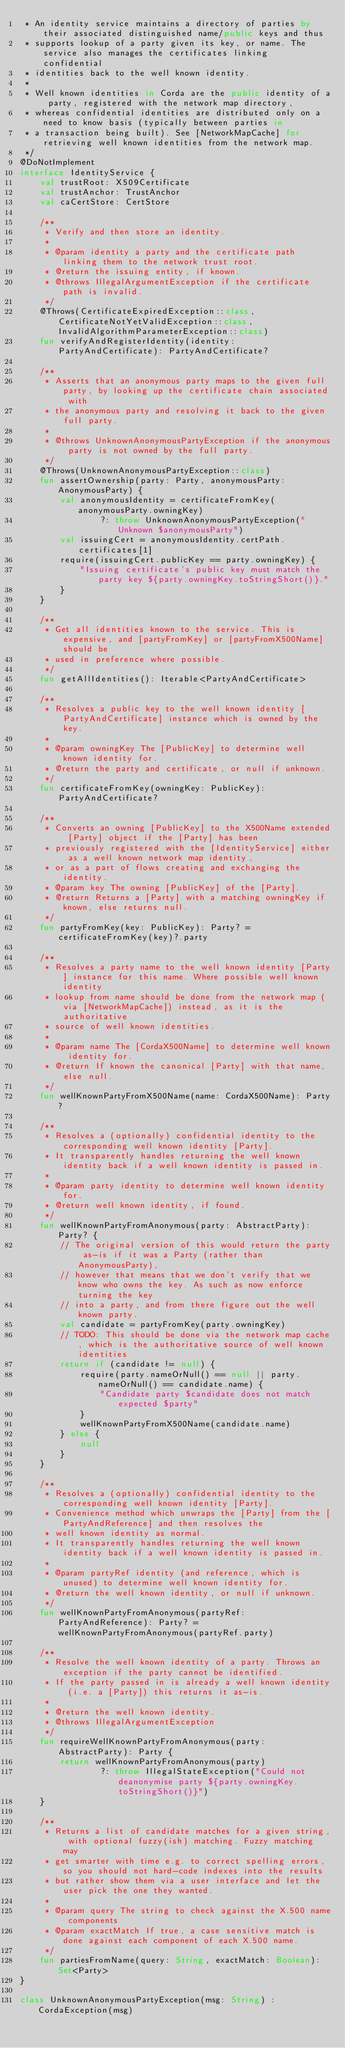Convert code to text. <code><loc_0><loc_0><loc_500><loc_500><_Kotlin_> * An identity service maintains a directory of parties by their associated distinguished name/public keys and thus
 * supports lookup of a party given its key, or name. The service also manages the certificates linking confidential
 * identities back to the well known identity.
 *
 * Well known identities in Corda are the public identity of a party, registered with the network map directory,
 * whereas confidential identities are distributed only on a need to know basis (typically between parties in
 * a transaction being built). See [NetworkMapCache] for retrieving well known identities from the network map.
 */
@DoNotImplement
interface IdentityService {
    val trustRoot: X509Certificate
    val trustAnchor: TrustAnchor
    val caCertStore: CertStore

    /**
     * Verify and then store an identity.
     *
     * @param identity a party and the certificate path linking them to the network trust root.
     * @return the issuing entity, if known.
     * @throws IllegalArgumentException if the certificate path is invalid.
     */
    @Throws(CertificateExpiredException::class, CertificateNotYetValidException::class, InvalidAlgorithmParameterException::class)
    fun verifyAndRegisterIdentity(identity: PartyAndCertificate): PartyAndCertificate?

    /**
     * Asserts that an anonymous party maps to the given full party, by looking up the certificate chain associated with
     * the anonymous party and resolving it back to the given full party.
     *
     * @throws UnknownAnonymousPartyException if the anonymous party is not owned by the full party.
     */
    @Throws(UnknownAnonymousPartyException::class)
    fun assertOwnership(party: Party, anonymousParty: AnonymousParty) {
        val anonymousIdentity = certificateFromKey(anonymousParty.owningKey)
                ?: throw UnknownAnonymousPartyException("Unknown $anonymousParty")
        val issuingCert = anonymousIdentity.certPath.certificates[1]
        require(issuingCert.publicKey == party.owningKey) {
            "Issuing certificate's public key must match the party key ${party.owningKey.toStringShort()}."
        }
    }

    /**
     * Get all identities known to the service. This is expensive, and [partyFromKey] or [partyFromX500Name] should be
     * used in preference where possible.
     */
    fun getAllIdentities(): Iterable<PartyAndCertificate>

    /**
     * Resolves a public key to the well known identity [PartyAndCertificate] instance which is owned by the key.
     *
     * @param owningKey The [PublicKey] to determine well known identity for.
     * @return the party and certificate, or null if unknown.
     */
    fun certificateFromKey(owningKey: PublicKey): PartyAndCertificate?

    /**
     * Converts an owning [PublicKey] to the X500Name extended [Party] object if the [Party] has been
     * previously registered with the [IdentityService] either as a well known network map identity,
     * or as a part of flows creating and exchanging the identity.
     * @param key The owning [PublicKey] of the [Party].
     * @return Returns a [Party] with a matching owningKey if known, else returns null.
     */
    fun partyFromKey(key: PublicKey): Party? = certificateFromKey(key)?.party

    /**
     * Resolves a party name to the well known identity [Party] instance for this name. Where possible well known identity
     * lookup from name should be done from the network map (via [NetworkMapCache]) instead, as it is the authoritative
     * source of well known identities.
     *
     * @param name The [CordaX500Name] to determine well known identity for.
     * @return If known the canonical [Party] with that name, else null.
     */
    fun wellKnownPartyFromX500Name(name: CordaX500Name): Party?

    /**
     * Resolves a (optionally) confidential identity to the corresponding well known identity [Party].
     * It transparently handles returning the well known identity back if a well known identity is passed in.
     *
     * @param party identity to determine well known identity for.
     * @return well known identity, if found.
     */
    fun wellKnownPartyFromAnonymous(party: AbstractParty): Party? {
        // The original version of this would return the party as-is if it was a Party (rather than AnonymousParty),
        // however that means that we don't verify that we know who owns the key. As such as now enforce turning the key
        // into a party, and from there figure out the well known party.
        val candidate = partyFromKey(party.owningKey)
        // TODO: This should be done via the network map cache, which is the authoritative source of well known identities
        return if (candidate != null) {
            require(party.nameOrNull() == null || party.nameOrNull() == candidate.name) {
                "Candidate party $candidate does not match expected $party"
            }
            wellKnownPartyFromX500Name(candidate.name)
        } else {
            null
        }
    }

    /**
     * Resolves a (optionally) confidential identity to the corresponding well known identity [Party].
     * Convenience method which unwraps the [Party] from the [PartyAndReference] and then resolves the
     * well known identity as normal.
     * It transparently handles returning the well known identity back if a well known identity is passed in.
     *
     * @param partyRef identity (and reference, which is unused) to determine well known identity for.
     * @return the well known identity, or null if unknown.
     */
    fun wellKnownPartyFromAnonymous(partyRef: PartyAndReference): Party? = wellKnownPartyFromAnonymous(partyRef.party)

    /**
     * Resolve the well known identity of a party. Throws an exception if the party cannot be identified.
     * If the party passed in is already a well known identity (i.e. a [Party]) this returns it as-is.
     *
     * @return the well known identity.
     * @throws IllegalArgumentException
     */
    fun requireWellKnownPartyFromAnonymous(party: AbstractParty): Party {
        return wellKnownPartyFromAnonymous(party)
                ?: throw IllegalStateException("Could not deanonymise party ${party.owningKey.toStringShort()}")
    }

    /**
     * Returns a list of candidate matches for a given string, with optional fuzzy(ish) matching. Fuzzy matching may
     * get smarter with time e.g. to correct spelling errors, so you should not hard-code indexes into the results
     * but rather show them via a user interface and let the user pick the one they wanted.
     *
     * @param query The string to check against the X.500 name components
     * @param exactMatch If true, a case sensitive match is done against each component of each X.500 name.
     */
    fun partiesFromName(query: String, exactMatch: Boolean): Set<Party>
}

class UnknownAnonymousPartyException(msg: String) : CordaException(msg)
</code> 